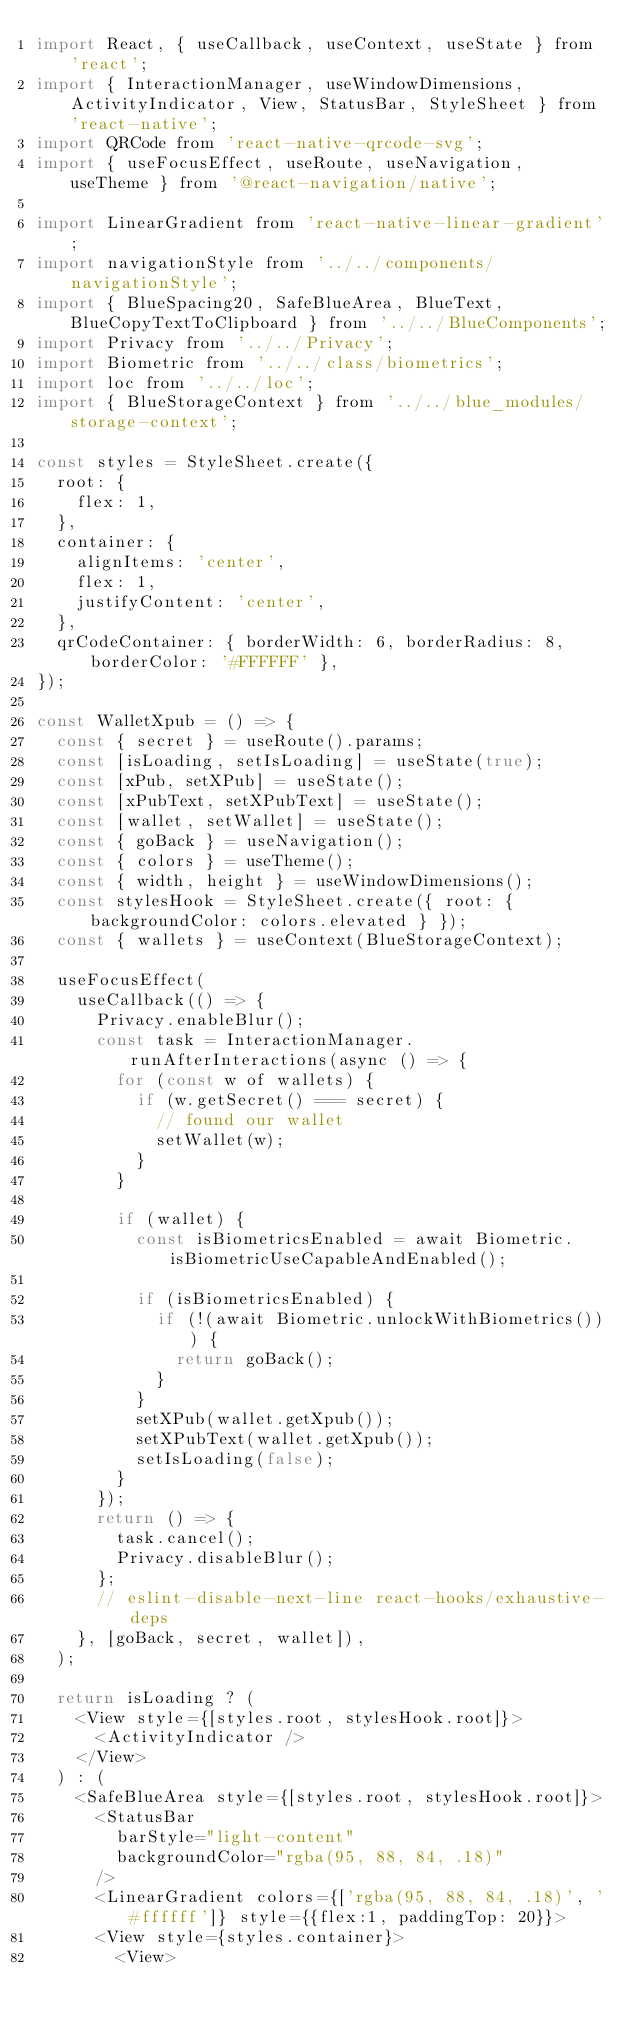Convert code to text. <code><loc_0><loc_0><loc_500><loc_500><_JavaScript_>import React, { useCallback, useContext, useState } from 'react';
import { InteractionManager, useWindowDimensions, ActivityIndicator, View, StatusBar, StyleSheet } from 'react-native';
import QRCode from 'react-native-qrcode-svg';
import { useFocusEffect, useRoute, useNavigation, useTheme } from '@react-navigation/native';

import LinearGradient from 'react-native-linear-gradient';
import navigationStyle from '../../components/navigationStyle';
import { BlueSpacing20, SafeBlueArea, BlueText, BlueCopyTextToClipboard } from '../../BlueComponents';
import Privacy from '../../Privacy';
import Biometric from '../../class/biometrics';
import loc from '../../loc';
import { BlueStorageContext } from '../../blue_modules/storage-context';

const styles = StyleSheet.create({
  root: {
    flex: 1,
  },
  container: {
    alignItems: 'center',
    flex: 1,
    justifyContent: 'center',
  },
  qrCodeContainer: { borderWidth: 6, borderRadius: 8, borderColor: '#FFFFFF' },
});

const WalletXpub = () => {
  const { secret } = useRoute().params;
  const [isLoading, setIsLoading] = useState(true);
  const [xPub, setXPub] = useState();
  const [xPubText, setXPubText] = useState();
  const [wallet, setWallet] = useState();
  const { goBack } = useNavigation();
  const { colors } = useTheme();
  const { width, height } = useWindowDimensions();
  const stylesHook = StyleSheet.create({ root: { backgroundColor: colors.elevated } });
  const { wallets } = useContext(BlueStorageContext);

  useFocusEffect(
    useCallback(() => {
      Privacy.enableBlur();
      const task = InteractionManager.runAfterInteractions(async () => {
        for (const w of wallets) {
          if (w.getSecret() === secret) {
            // found our wallet
            setWallet(w);
          }
        }

        if (wallet) {
          const isBiometricsEnabled = await Biometric.isBiometricUseCapableAndEnabled();

          if (isBiometricsEnabled) {
            if (!(await Biometric.unlockWithBiometrics())) {
              return goBack();
            }
          }
          setXPub(wallet.getXpub());
          setXPubText(wallet.getXpub());
          setIsLoading(false);
        }
      });
      return () => {
        task.cancel();
        Privacy.disableBlur();
      };
      // eslint-disable-next-line react-hooks/exhaustive-deps
    }, [goBack, secret, wallet]),
  );

  return isLoading ? (
    <View style={[styles.root, stylesHook.root]}>
      <ActivityIndicator />
    </View>
  ) : (
    <SafeBlueArea style={[styles.root, stylesHook.root]}>
      <StatusBar 
        barStyle="light-content"
        backgroundColor="rgba(95, 88, 84, .18)"
      />
      <LinearGradient colors={['rgba(95, 88, 84, .18)', '#ffffff']} style={{flex:1, paddingTop: 20}}>
      <View style={styles.container}>
        <View></code> 